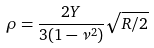<formula> <loc_0><loc_0><loc_500><loc_500>\rho = \frac { 2 Y } { 3 ( 1 - \nu ^ { 2 } ) } \sqrt { R / 2 }</formula> 